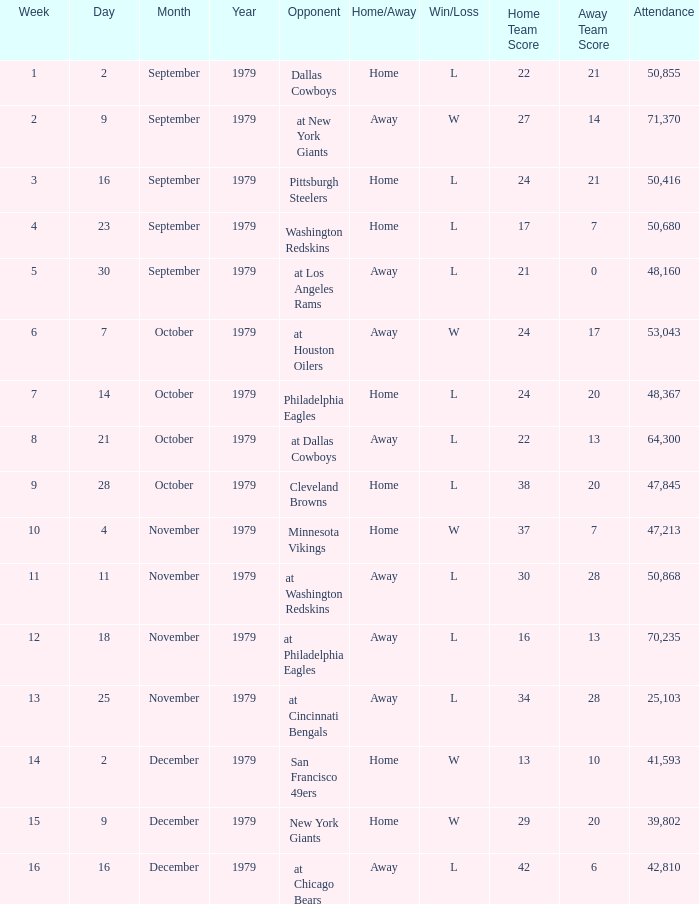What is the highest week when attendance is greater than 64,300 with a result of w 27-14? 2.0. 